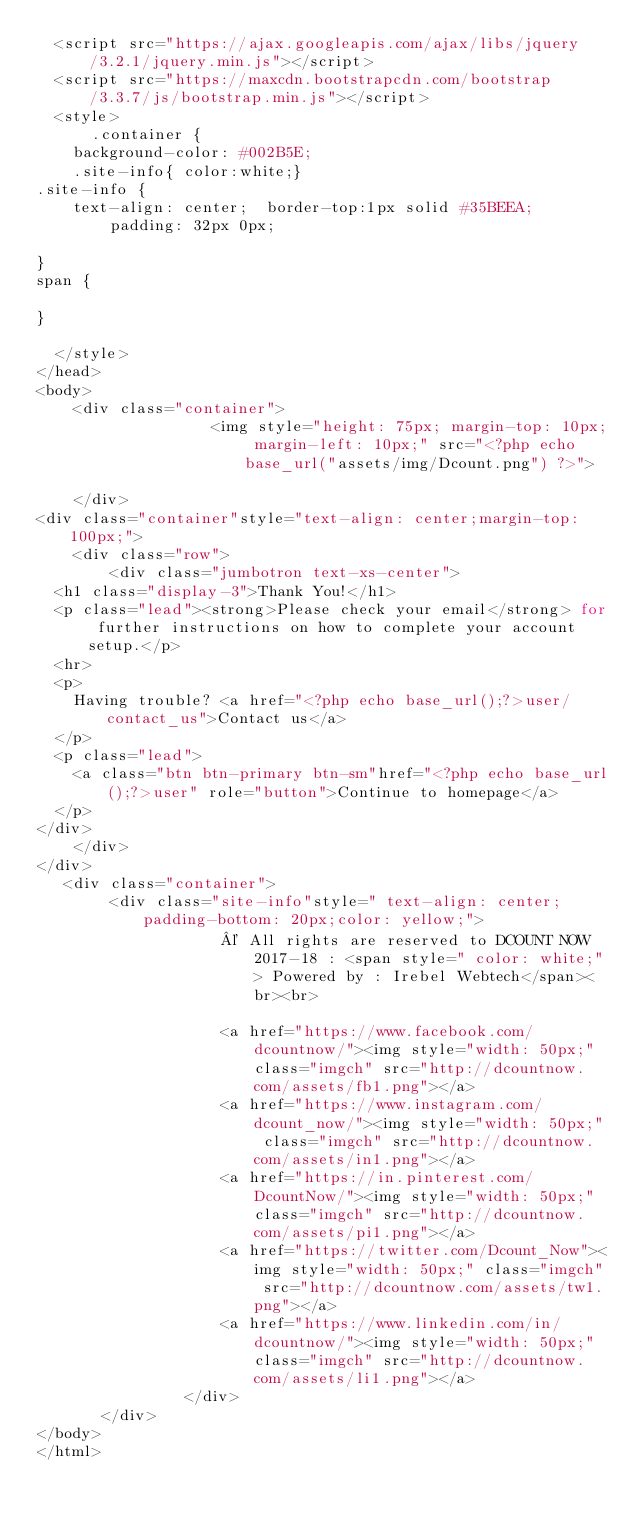Convert code to text. <code><loc_0><loc_0><loc_500><loc_500><_PHP_>  <script src="https://ajax.googleapis.com/ajax/libs/jquery/3.2.1/jquery.min.js"></script>
  <script src="https://maxcdn.bootstrapcdn.com/bootstrap/3.3.7/js/bootstrap.min.js"></script>
  <style>
      .container {
    background-color: #002B5E;
    .site-info{ color:white;}
.site-info {
    text-align: center;  border-top:1px solid #35BEEA;
        padding: 32px 0px;

}
span {
   
}

  </style>
</head>
<body>
    <div class="container">
                   <img style="height: 75px; margin-top: 10px; margin-left: 10px;" src="<?php echo base_url("assets/img/Dcount.png") ?>">

    </div>
<div class="container"style="text-align: center;margin-top: 100px;">
    <div class="row">
        <div class="jumbotron text-xs-center">
  <h1 class="display-3">Thank You!</h1>
  <p class="lead"><strong>Please check your email</strong> for further instructions on how to complete your account setup.</p>
  <hr>
  <p>
    Having trouble? <a href="<?php echo base_url();?>user/contact_us">Contact us</a>
  </p>
  <p class="lead">
    <a class="btn btn-primary btn-sm"href="<?php echo base_url();?>user" role="button">Continue to homepage</a>
  </p>
</div>
    </div>
</div> 
   <div class="container">
        <div class="site-info"style=" text-align: center;  padding-bottom: 20px;color: yellow;">
				   	© All rights are reserved to DCOUNT NOW 2017-18 : <span style=" color: white;"> Powered by : Irebel Webtech</span><br><br>
					
					<a href="https://www.facebook.com/dcountnow/"><img style="width: 50px;" class="imgch" src="http://dcountnow.com/assets/fb1.png"></a>
					<a href="https://www.instagram.com/dcount_now/"><img style="width: 50px;" class="imgch" src="http://dcountnow.com/assets/in1.png"></a>
					<a href="https://in.pinterest.com/DcountNow/"><img style="width: 50px;" class="imgch" src="http://dcountnow.com/assets/pi1.png"></a>
					<a href="https://twitter.com/Dcount_Now"><img style="width: 50px;" class="imgch" src="http://dcountnow.com/assets/tw1.png"></a>
					<a href="https://www.linkedin.com/in/dcountnow/"><img style="width: 50px;" class="imgch" src="http://dcountnow.com/assets/li1.png"></a>
				</div>
       </div>
</body>
</html>
</code> 